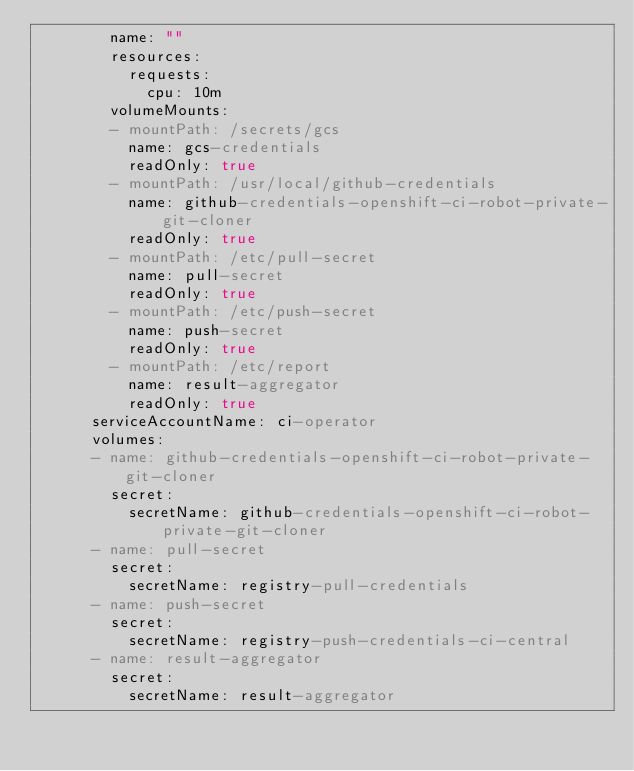<code> <loc_0><loc_0><loc_500><loc_500><_YAML_>        name: ""
        resources:
          requests:
            cpu: 10m
        volumeMounts:
        - mountPath: /secrets/gcs
          name: gcs-credentials
          readOnly: true
        - mountPath: /usr/local/github-credentials
          name: github-credentials-openshift-ci-robot-private-git-cloner
          readOnly: true
        - mountPath: /etc/pull-secret
          name: pull-secret
          readOnly: true
        - mountPath: /etc/push-secret
          name: push-secret
          readOnly: true
        - mountPath: /etc/report
          name: result-aggregator
          readOnly: true
      serviceAccountName: ci-operator
      volumes:
      - name: github-credentials-openshift-ci-robot-private-git-cloner
        secret:
          secretName: github-credentials-openshift-ci-robot-private-git-cloner
      - name: pull-secret
        secret:
          secretName: registry-pull-credentials
      - name: push-secret
        secret:
          secretName: registry-push-credentials-ci-central
      - name: result-aggregator
        secret:
          secretName: result-aggregator
</code> 